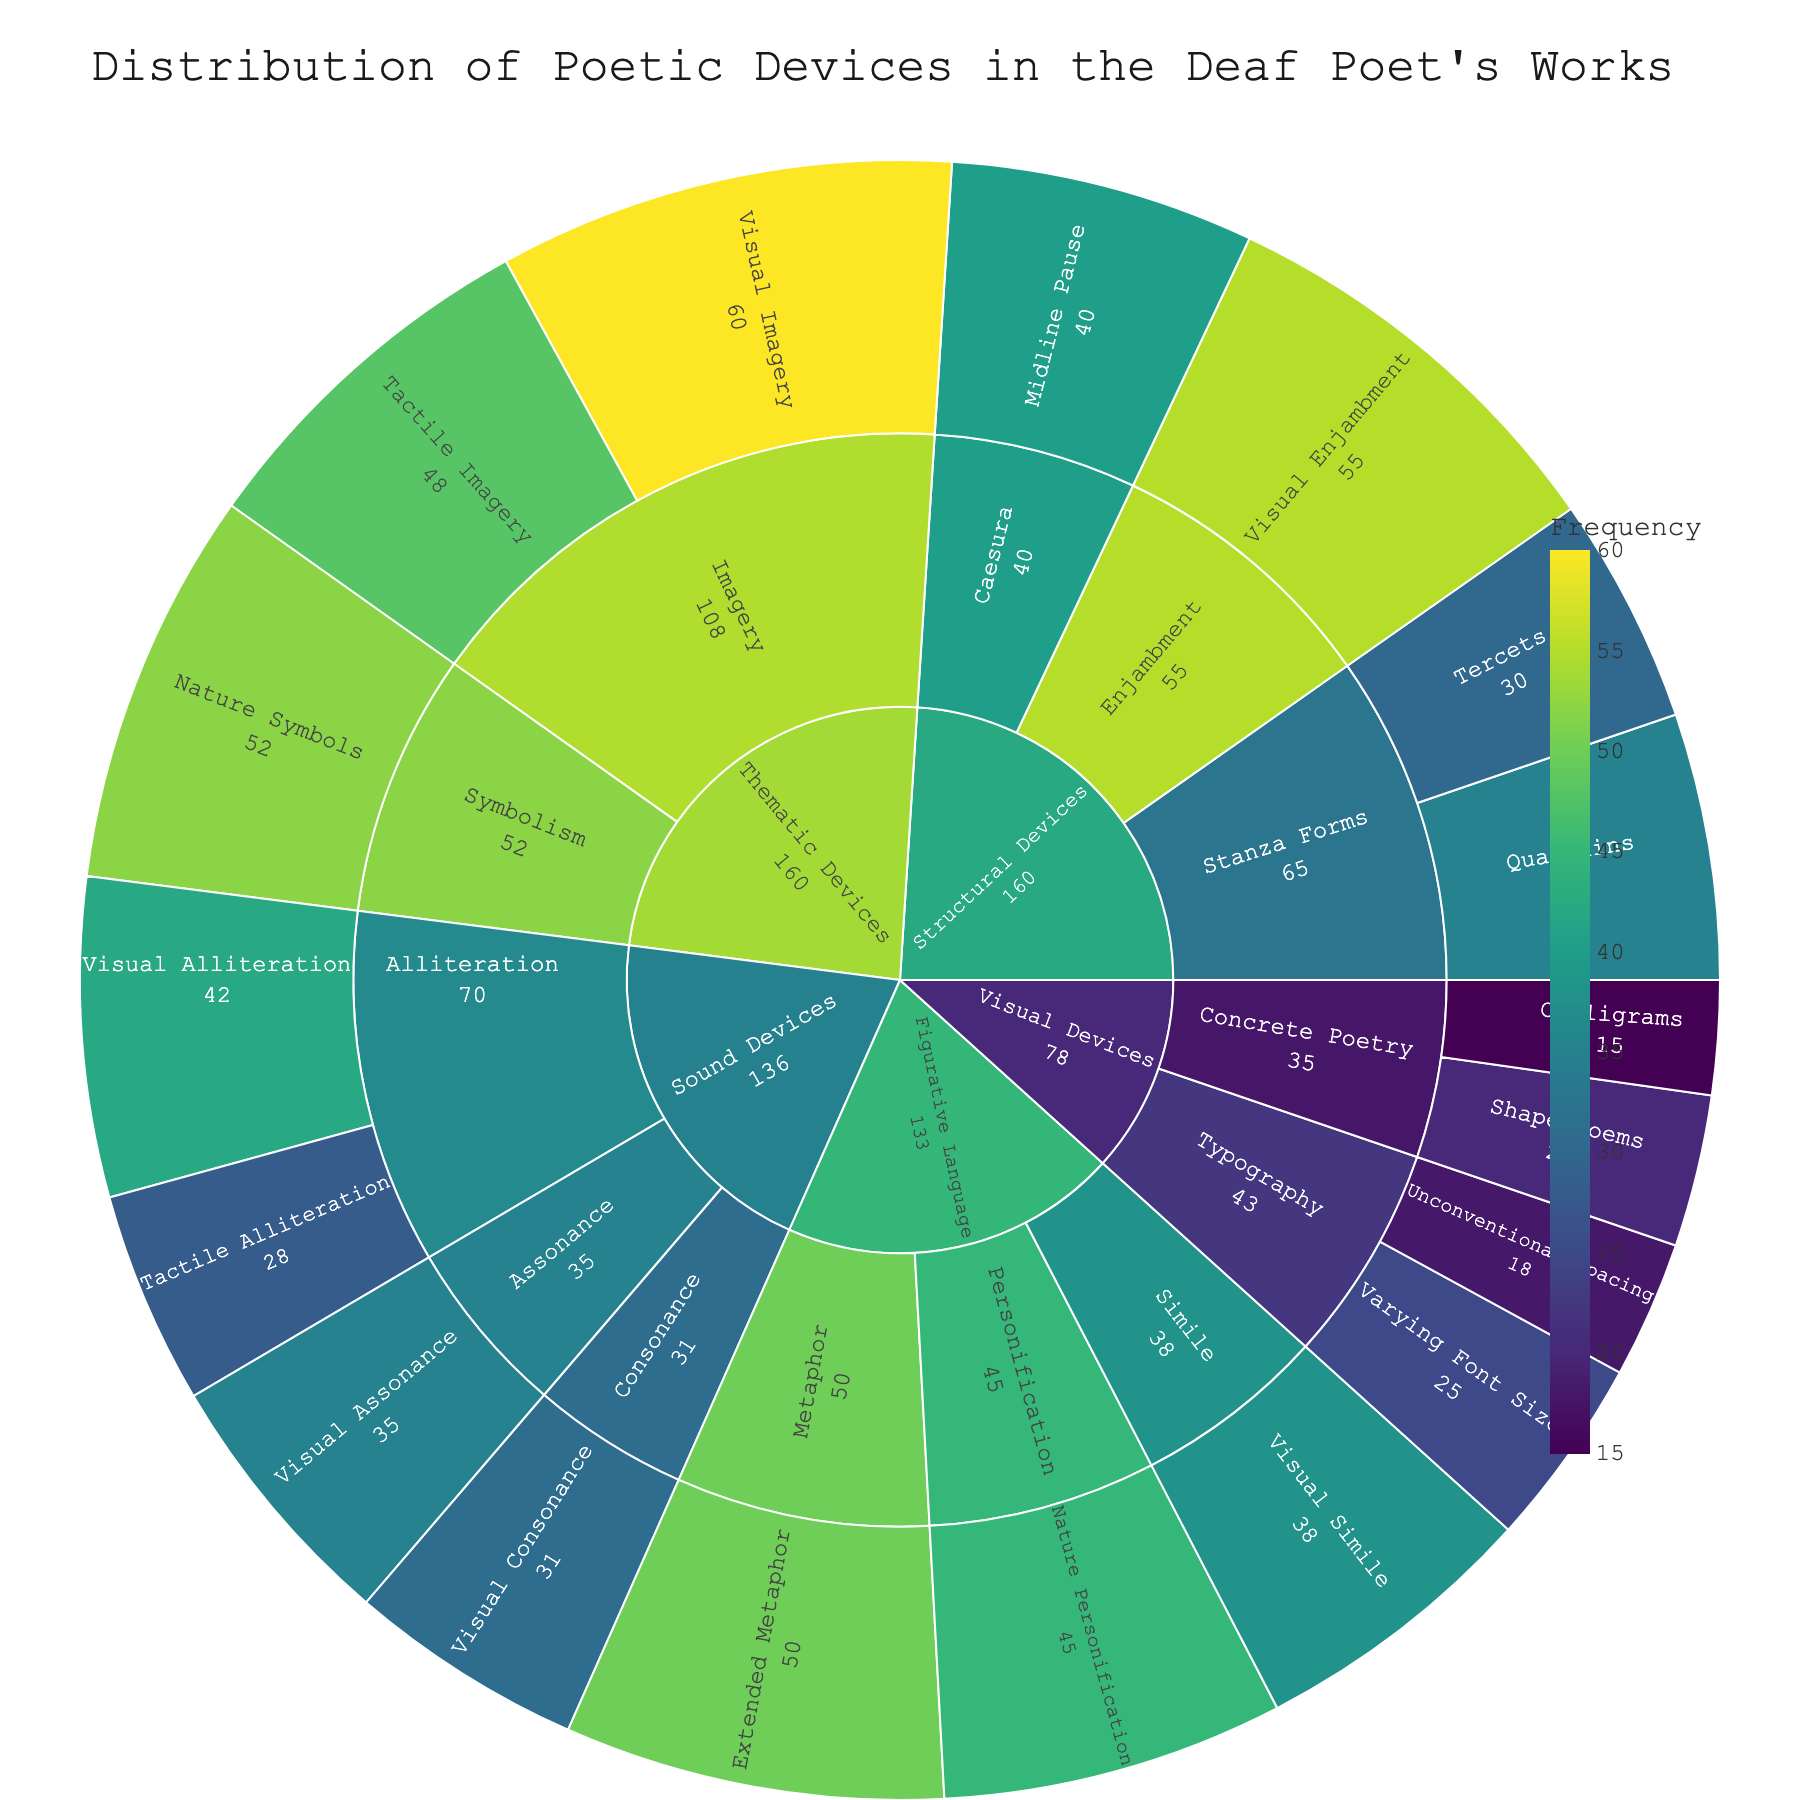What's the title of the plot? The title is typically located at the top of the plot and provides a summary of what the plot represents.
Answer: Distribution of Poetic Devices in the Deaf Poet's Works Which poetic device has the highest frequency? To identify the highest frequency, look for the segment with the largest value or the one that stands out most in the color spectrum showing frequency.
Answer: Visual Imagery How many subcategories are there within Visual Devices? Visual Devices are represented as a segment; inside this segment, count the distinct subsegments to determine the number of subcategories.
Answer: 2 (Concrete Poetry and Typography) What's the combined frequency of Tactile Imagery and Nature Symbols? Locate Tactile Imagery and Nature Symbols, note their frequencies, and add them together: 48 (Tactile Imagery) + 52 (Nature Symbols).
Answer: 100 Which category has the least number of subcategories? Compare the number of subcategories within each main category by counting the inner segments.
Answer: Thematic Devices Is the total frequency of the devices under Sound Devices greater than that under Visual Devices? Sum up the frequencies of the devices under each category: Sound Devices (42+28+35+31) and Visual Devices (20+15+25+18); then compare the totals.
Answer: Yes What is the sum of the frequencies for the devices in the Figurative Language category? Add up the frequencies of all devices under Figurative Language: 50 (Extended Metaphor) + 38 (Visual Simile) + 45 (Nature Personification).
Answer: 133 Which category includes Stanza Forms and how many types of stanza forms are shown? Locate Stanza Forms and identify its parent category; then count the subcategories within Stanza Forms section.
Answer: Structural Devices, 2 types (Tercets and Quatrains) How does the frequency of Midline Pause compare to that of Visual Alliteration? Identify the frequencies of Midline Pause and Visual Alliteration, then compare them to see which is greater.
Answer: Visual Alliteration is greater How many poetic devices have a frequency above 40? Examine all the frequencies and count how many values are above 40.
Answer: 8 